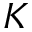Convert formula to latex. <formula><loc_0><loc_0><loc_500><loc_500>K</formula> 